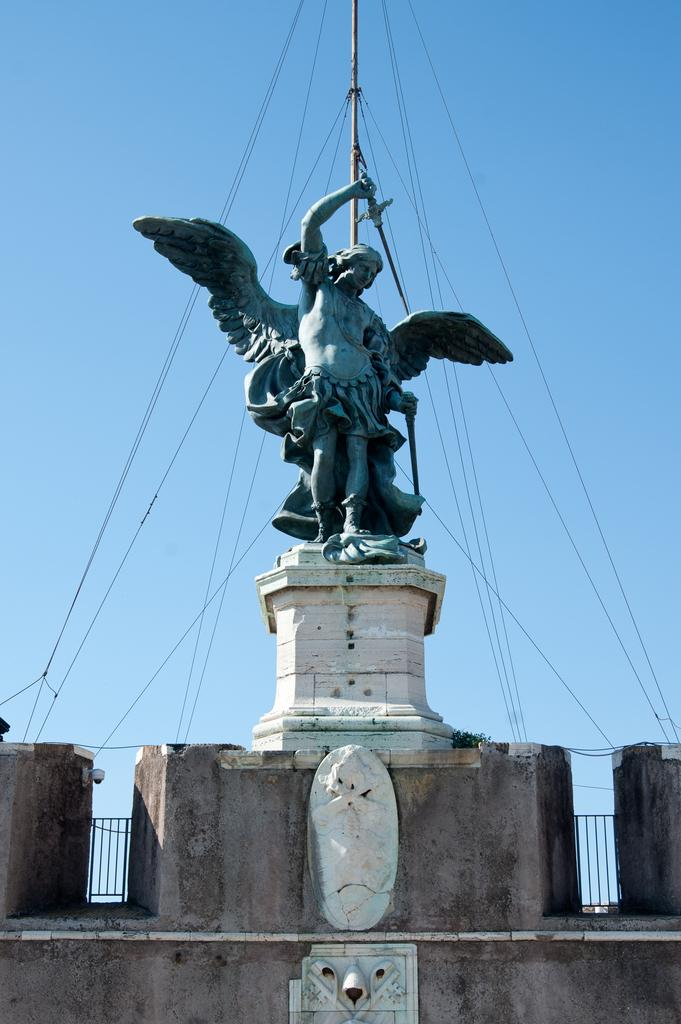What is located in the foreground of the image? There is a sculpture on a stone in the foreground of the image. What else can be seen on the stone in the foreground? There are structures on the stone in the foreground of the image. What is happening in the background of the image? There are ropes attached to a pole in the background of the image. What can be seen in the sky in the background of the image? The sky is visible in the background of the image. What type of apparel is the donkey wearing in the image? There is no donkey present in the image, so it is not possible to determine what type of apparel it might be wearing. 